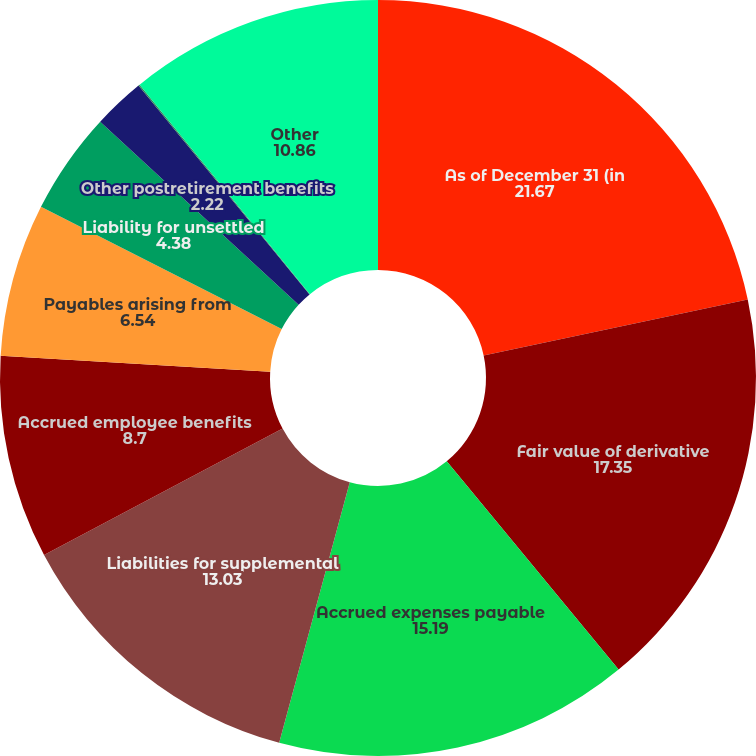<chart> <loc_0><loc_0><loc_500><loc_500><pie_chart><fcel>As of December 31 (in<fcel>Fair value of derivative<fcel>Accrued expenses payable<fcel>Liabilities for supplemental<fcel>Accrued employee benefits<fcel>Payables arising from<fcel>Liability for unsettled<fcel>Other postretirement benefits<fcel>Accrued interest payable<fcel>Other<nl><fcel>21.67%<fcel>17.35%<fcel>15.19%<fcel>13.03%<fcel>8.7%<fcel>6.54%<fcel>4.38%<fcel>2.22%<fcel>0.06%<fcel>10.86%<nl></chart> 